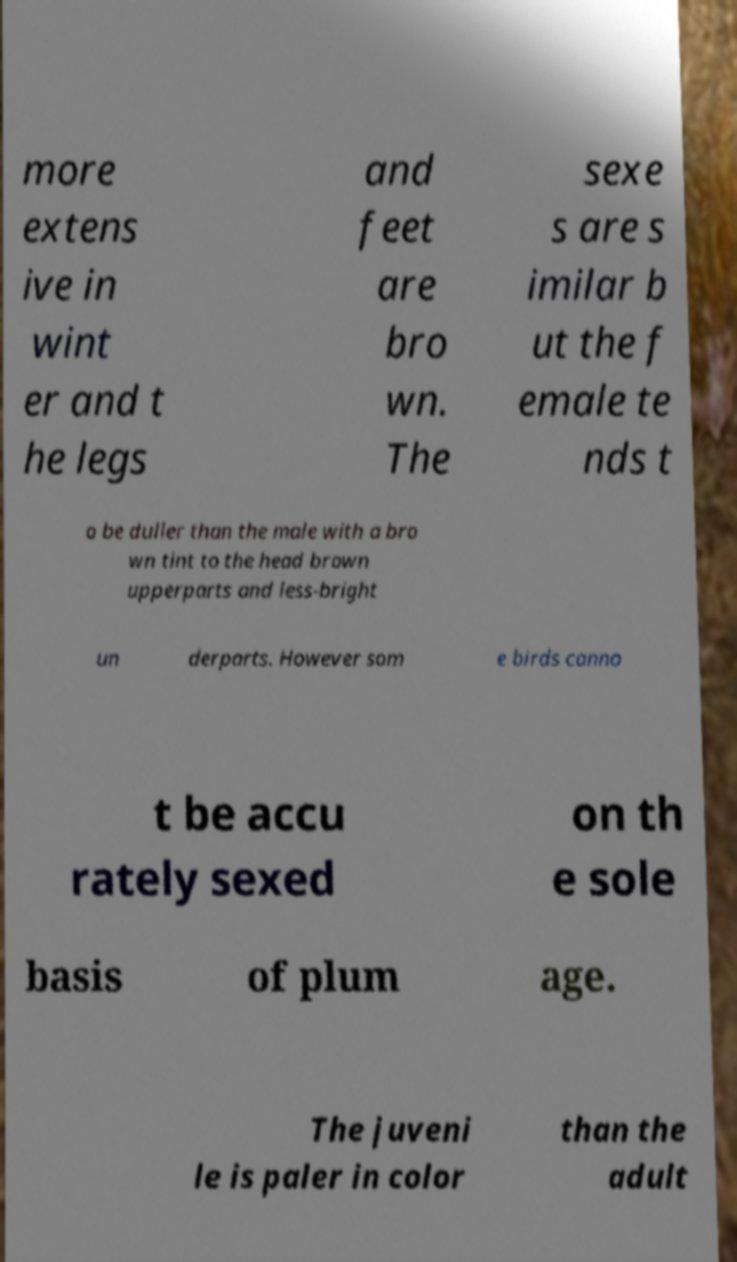What messages or text are displayed in this image? I need them in a readable, typed format. more extens ive in wint er and t he legs and feet are bro wn. The sexe s are s imilar b ut the f emale te nds t o be duller than the male with a bro wn tint to the head brown upperparts and less-bright un derparts. However som e birds canno t be accu rately sexed on th e sole basis of plum age. The juveni le is paler in color than the adult 